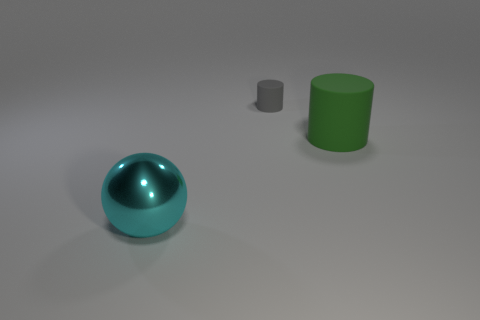There is a big cyan metallic thing in front of the big thing to the right of the large object that is left of the green cylinder; what is its shape?
Keep it short and to the point. Sphere. How many objects are cyan metal objects or things right of the cyan thing?
Ensure brevity in your answer.  3. There is a big object to the right of the cyan shiny object; is its shape the same as the big thing to the left of the green cylinder?
Provide a succinct answer. No. How many things are either large red metal blocks or cylinders?
Provide a short and direct response. 2. Is there anything else that has the same material as the tiny gray cylinder?
Your answer should be compact. Yes. Are any tiny yellow rubber spheres visible?
Keep it short and to the point. No. Does the large object right of the big cyan object have the same material as the large cyan thing?
Make the answer very short. No. Is there a big cyan metal object that has the same shape as the big green thing?
Offer a terse response. No. Is the number of tiny matte things that are on the right side of the large green matte object the same as the number of big purple metallic objects?
Offer a very short reply. Yes. The cylinder behind the large object to the right of the big ball is made of what material?
Offer a terse response. Rubber. 